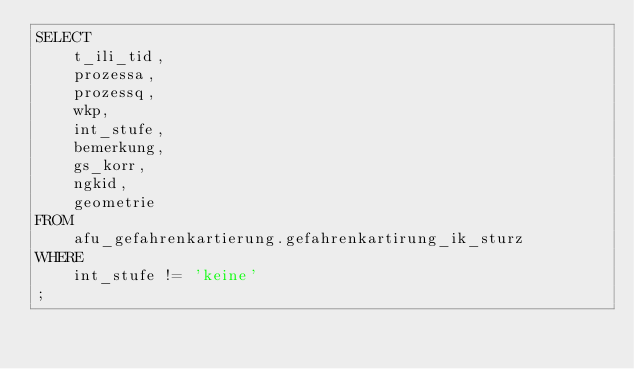Convert code to text. <code><loc_0><loc_0><loc_500><loc_500><_SQL_>SELECT 
	t_ili_tid, 
	prozessa, 
	prozessq, 
	wkp, 
	int_stufe, 
	bemerkung, 
	gs_korr, 
	ngkid, 
	geometrie
FROM 
	afu_gefahrenkartierung.gefahrenkartirung_ik_sturz
WHERE
	int_stufe != 'keine'
;
</code> 